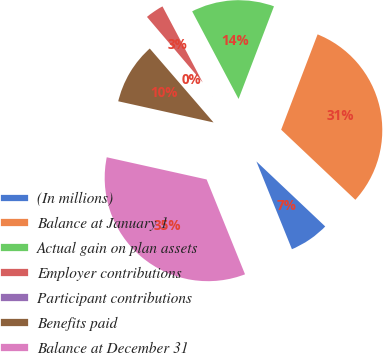Convert chart to OTSL. <chart><loc_0><loc_0><loc_500><loc_500><pie_chart><fcel>(In millions)<fcel>Balance at January 1<fcel>Actual gain on plan assets<fcel>Employer contributions<fcel>Participant contributions<fcel>Benefits paid<fcel>Balance at December 31<nl><fcel>6.83%<fcel>31.24%<fcel>13.56%<fcel>3.47%<fcel>0.11%<fcel>10.19%<fcel>34.6%<nl></chart> 